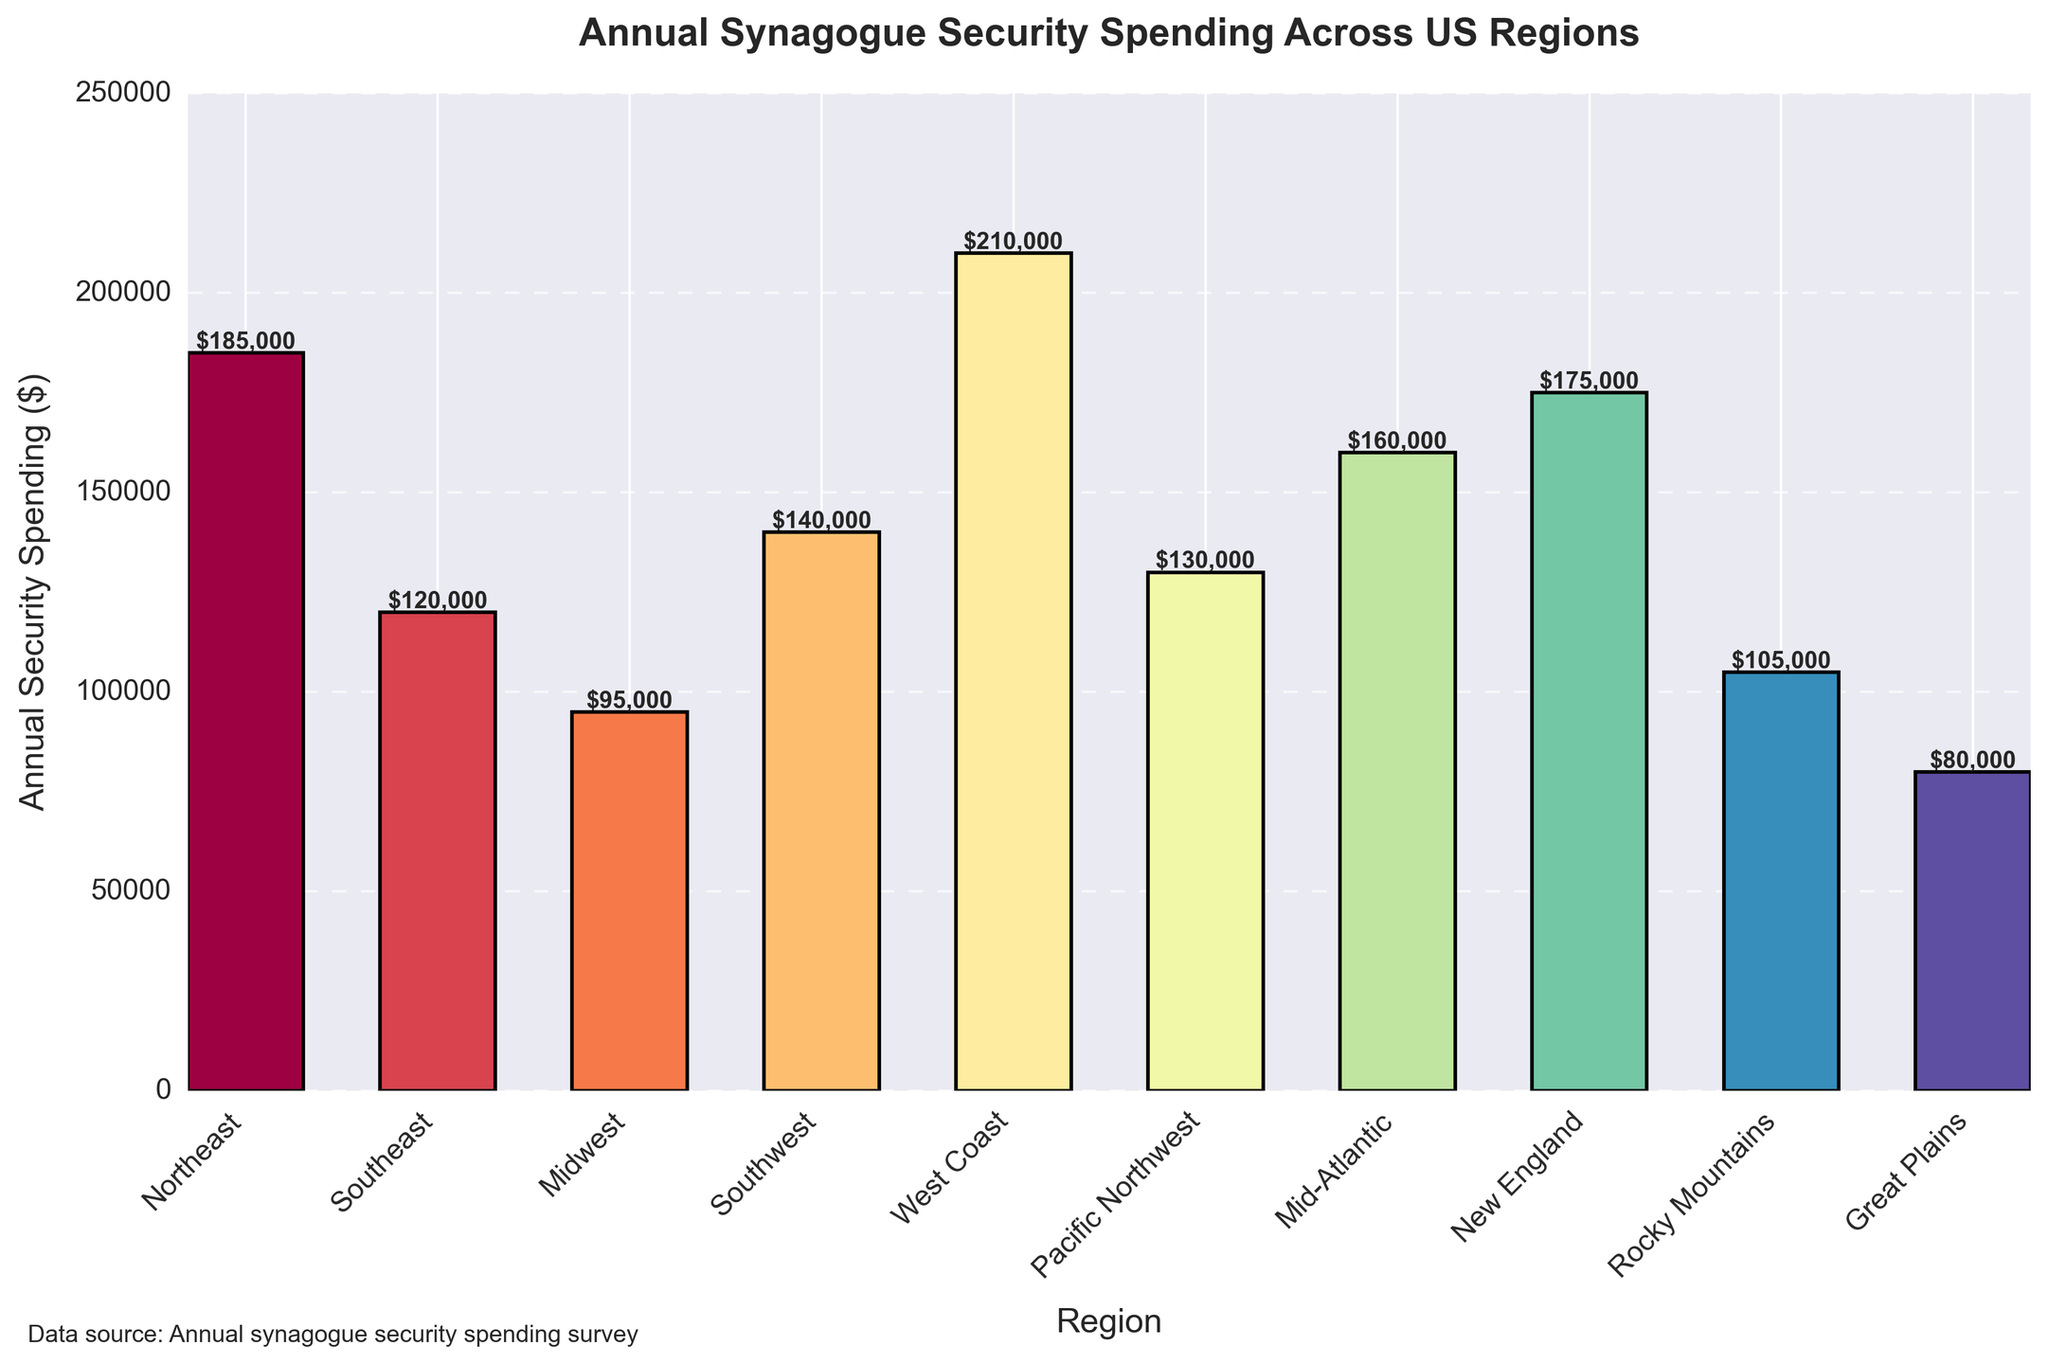What's the highest annual security spending among all regions? The highest bar represents the West Coast region with a height of $210,000.
Answer: $210,000 Which region has the lowest annual security spending? The bar with the smallest height is for the Great Plains region, which is $80,000.
Answer: Great Plains How much more does the West Coast spend on security compared to the Midwest? The height of the West Coast bar is $210,000, and the Midwest bar is $95,000. The difference is $210,000 - $95,000 = $115,000.
Answer: $115,000 What is the total annual security spending for the Northeast, Southeast, and Midwest regions combined? Sum the heights of the bars for these regions: $185,000 (Northeast) + $120,000 (Southeast) + $95,000 (Midwest) = $400,000.
Answer: $400,000 Are there more regions spending above $150,000 or below $150,000? Count the bars that exceed $150,000 (Northeast, West Coast, Mid-Atlantic, New England) and count the bars below $150,000 (Southeast, Midwest, Southwest, Pacific Northwest, Rocky Mountains, Great Plains). There are 4 bars above and 6 below $150,000.
Answer: Below $150,000 What's the median annual security spending for the regions? Arrange the spending values in ascending order: $80,000, $95,000, $105,000, $120,000, $130,000, $140,000, $160,000, $175,000, $185,000, $210,000. The median spending is the average of the 5th and 6th values: ($140,000 + $130,000)/2 = $135,000.
Answer: $135,000 